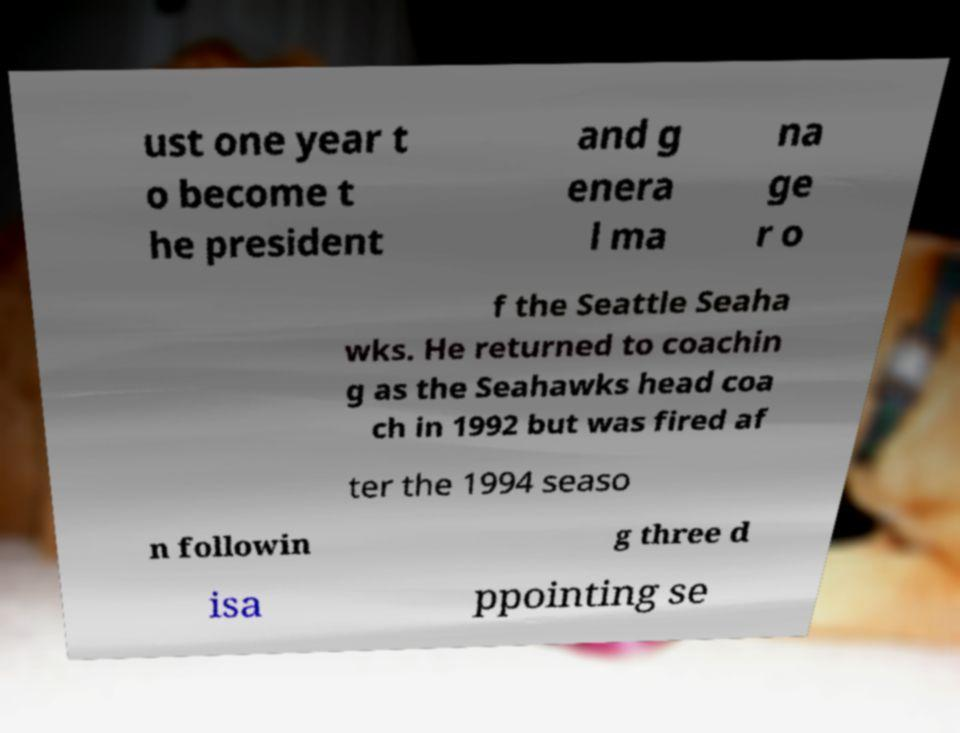Can you accurately transcribe the text from the provided image for me? ust one year t o become t he president and g enera l ma na ge r o f the Seattle Seaha wks. He returned to coachin g as the Seahawks head coa ch in 1992 but was fired af ter the 1994 seaso n followin g three d isa ppointing se 